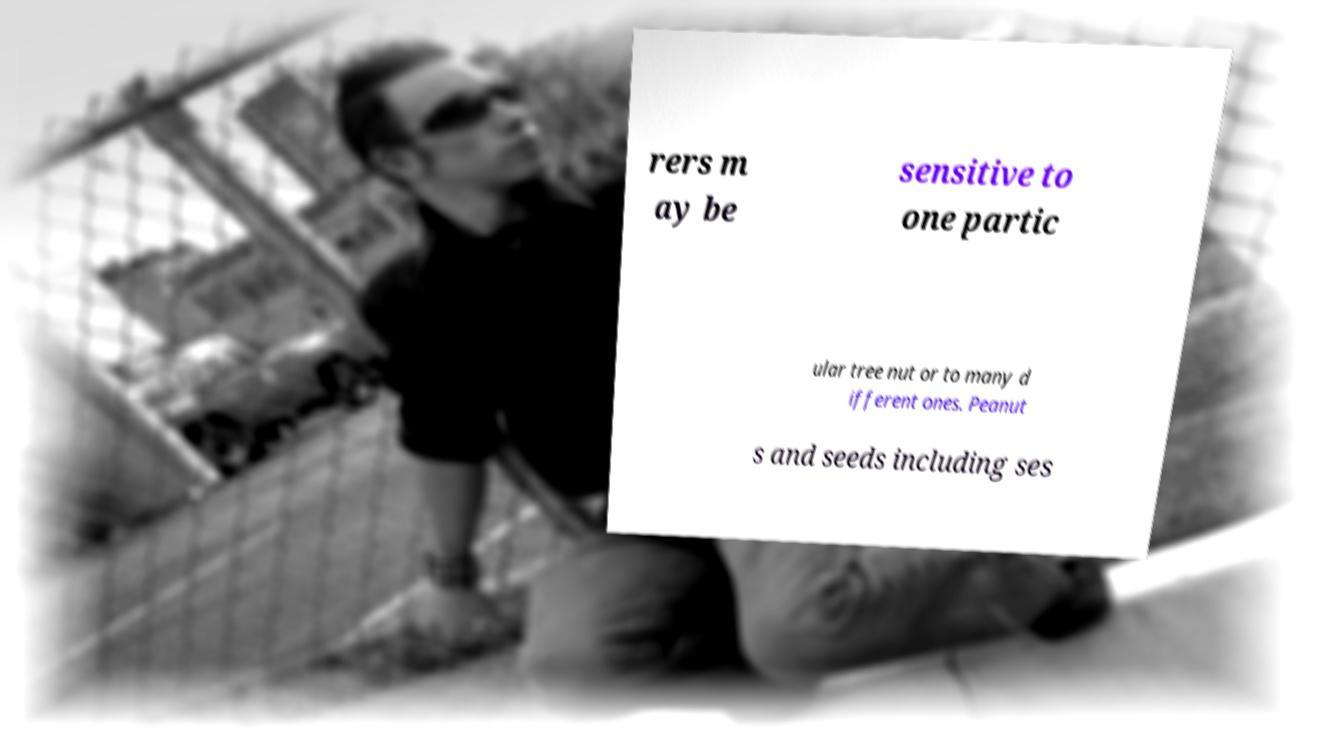Can you read and provide the text displayed in the image?This photo seems to have some interesting text. Can you extract and type it out for me? rers m ay be sensitive to one partic ular tree nut or to many d ifferent ones. Peanut s and seeds including ses 